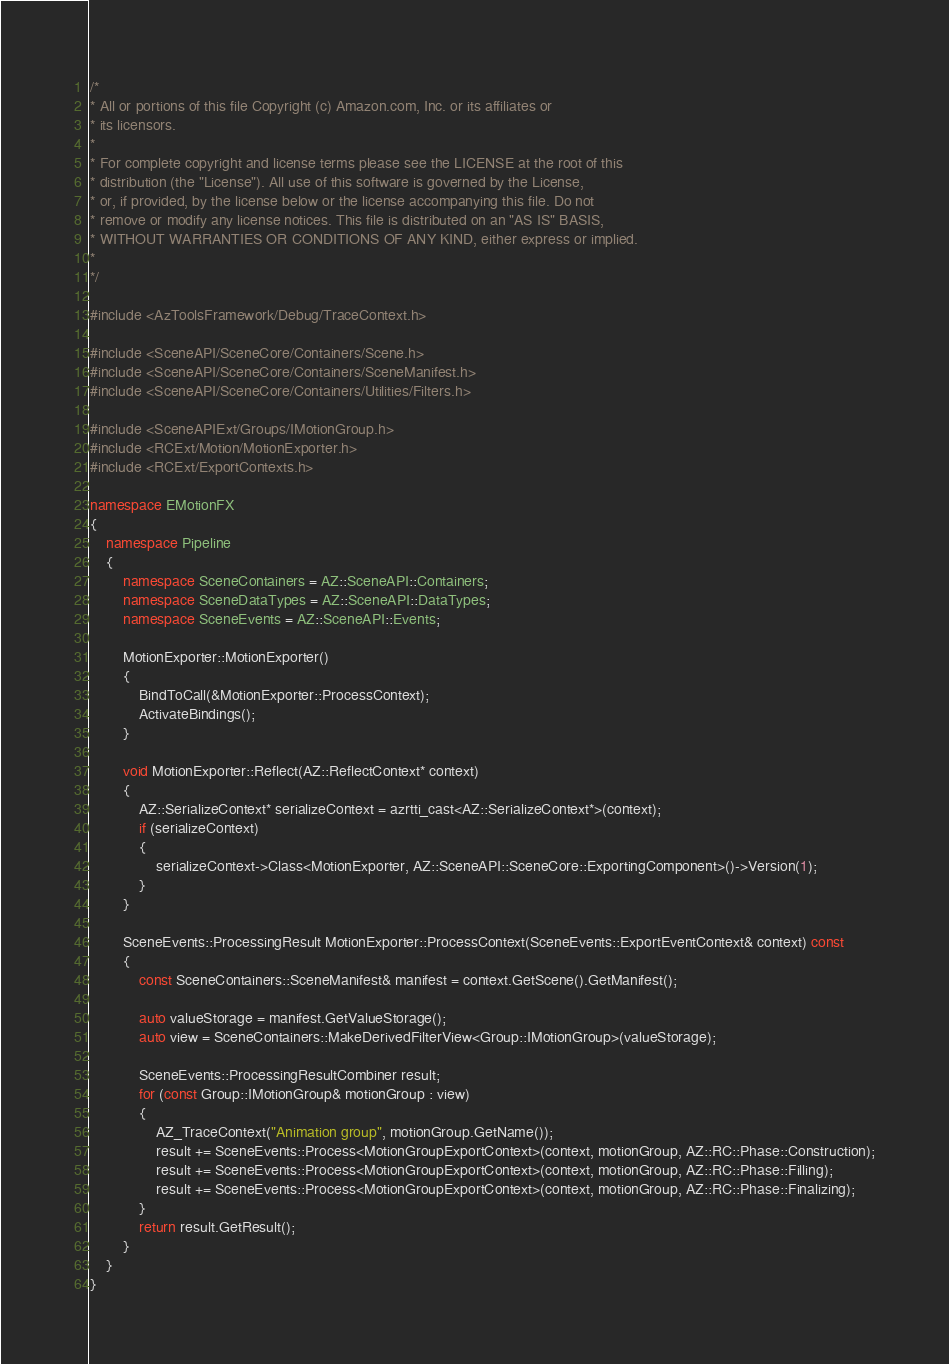Convert code to text. <code><loc_0><loc_0><loc_500><loc_500><_C++_>/*
* All or portions of this file Copyright (c) Amazon.com, Inc. or its affiliates or
* its licensors.
*
* For complete copyright and license terms please see the LICENSE at the root of this
* distribution (the "License"). All use of this software is governed by the License,
* or, if provided, by the license below or the license accompanying this file. Do not
* remove or modify any license notices. This file is distributed on an "AS IS" BASIS,
* WITHOUT WARRANTIES OR CONDITIONS OF ANY KIND, either express or implied.
*
*/

#include <AzToolsFramework/Debug/TraceContext.h>

#include <SceneAPI/SceneCore/Containers/Scene.h>
#include <SceneAPI/SceneCore/Containers/SceneManifest.h>
#include <SceneAPI/SceneCore/Containers/Utilities/Filters.h>

#include <SceneAPIExt/Groups/IMotionGroup.h>
#include <RCExt/Motion/MotionExporter.h>
#include <RCExt/ExportContexts.h>

namespace EMotionFX
{
    namespace Pipeline
    {
        namespace SceneContainers = AZ::SceneAPI::Containers;
        namespace SceneDataTypes = AZ::SceneAPI::DataTypes;
        namespace SceneEvents = AZ::SceneAPI::Events;

        MotionExporter::MotionExporter()
        {
            BindToCall(&MotionExporter::ProcessContext);
            ActivateBindings();
        }

        void MotionExporter::Reflect(AZ::ReflectContext* context)
        {
            AZ::SerializeContext* serializeContext = azrtti_cast<AZ::SerializeContext*>(context);
            if (serializeContext)
            {
                serializeContext->Class<MotionExporter, AZ::SceneAPI::SceneCore::ExportingComponent>()->Version(1);
            }
        }

        SceneEvents::ProcessingResult MotionExporter::ProcessContext(SceneEvents::ExportEventContext& context) const
        {
            const SceneContainers::SceneManifest& manifest = context.GetScene().GetManifest();

            auto valueStorage = manifest.GetValueStorage();
            auto view = SceneContainers::MakeDerivedFilterView<Group::IMotionGroup>(valueStorage);

            SceneEvents::ProcessingResultCombiner result;
            for (const Group::IMotionGroup& motionGroup : view)
            {
                AZ_TraceContext("Animation group", motionGroup.GetName());
                result += SceneEvents::Process<MotionGroupExportContext>(context, motionGroup, AZ::RC::Phase::Construction);
                result += SceneEvents::Process<MotionGroupExportContext>(context, motionGroup, AZ::RC::Phase::Filling);
                result += SceneEvents::Process<MotionGroupExportContext>(context, motionGroup, AZ::RC::Phase::Finalizing);
            }
            return result.GetResult();
        }
    }
}
</code> 